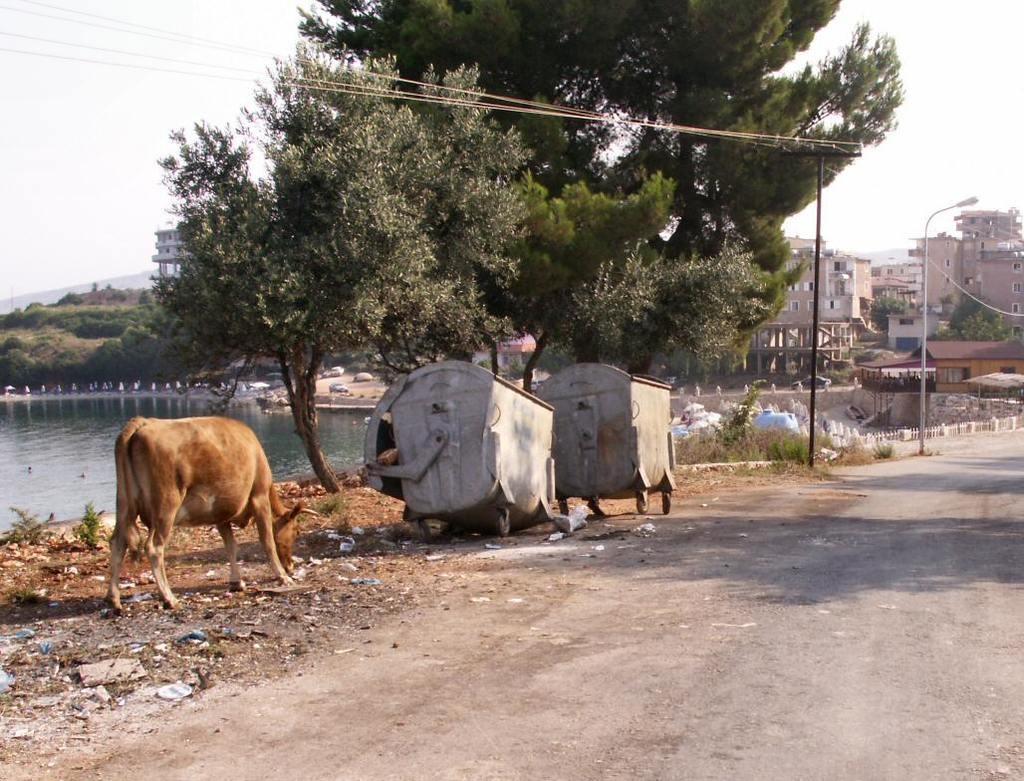Can you describe this image briefly? In this image there is a road, beside the road there are dustbins, a cow trees, in the background there is a pond, poles and houses. 